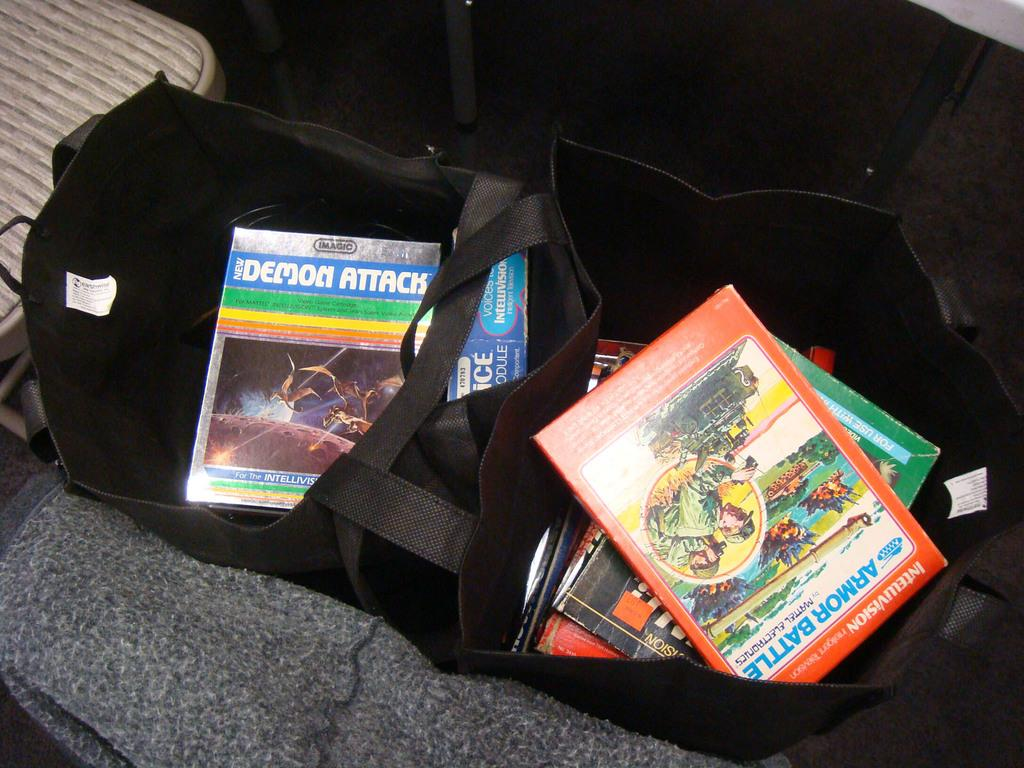<image>
Describe the image concisely. In two tote bags there are books, one book is called Demon Attack. 